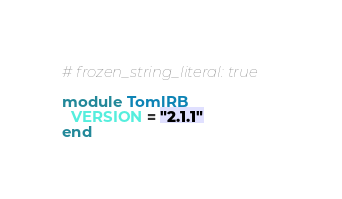<code> <loc_0><loc_0><loc_500><loc_500><_Ruby_># frozen_string_literal: true

module TomlRB
  VERSION = "2.1.1"
end
</code> 